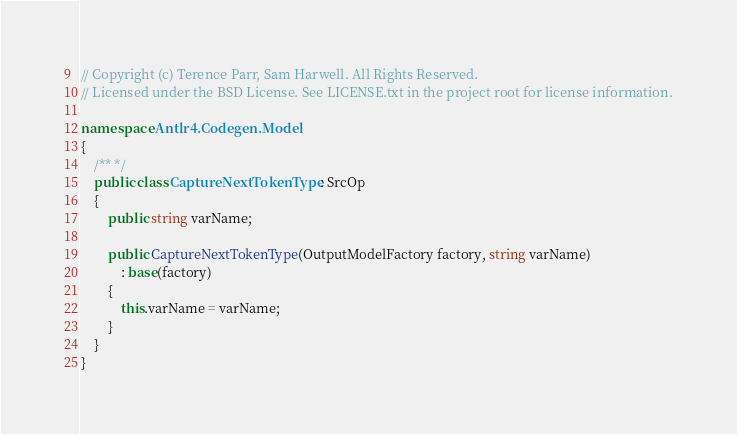<code> <loc_0><loc_0><loc_500><loc_500><_C#_>// Copyright (c) Terence Parr, Sam Harwell. All Rights Reserved.
// Licensed under the BSD License. See LICENSE.txt in the project root for license information.

namespace Antlr4.Codegen.Model
{
    /** */
    public class CaptureNextTokenType : SrcOp
    {
        public string varName;

        public CaptureNextTokenType(OutputModelFactory factory, string varName)
            : base(factory)
        {
            this.varName = varName;
        }
    }
}
</code> 